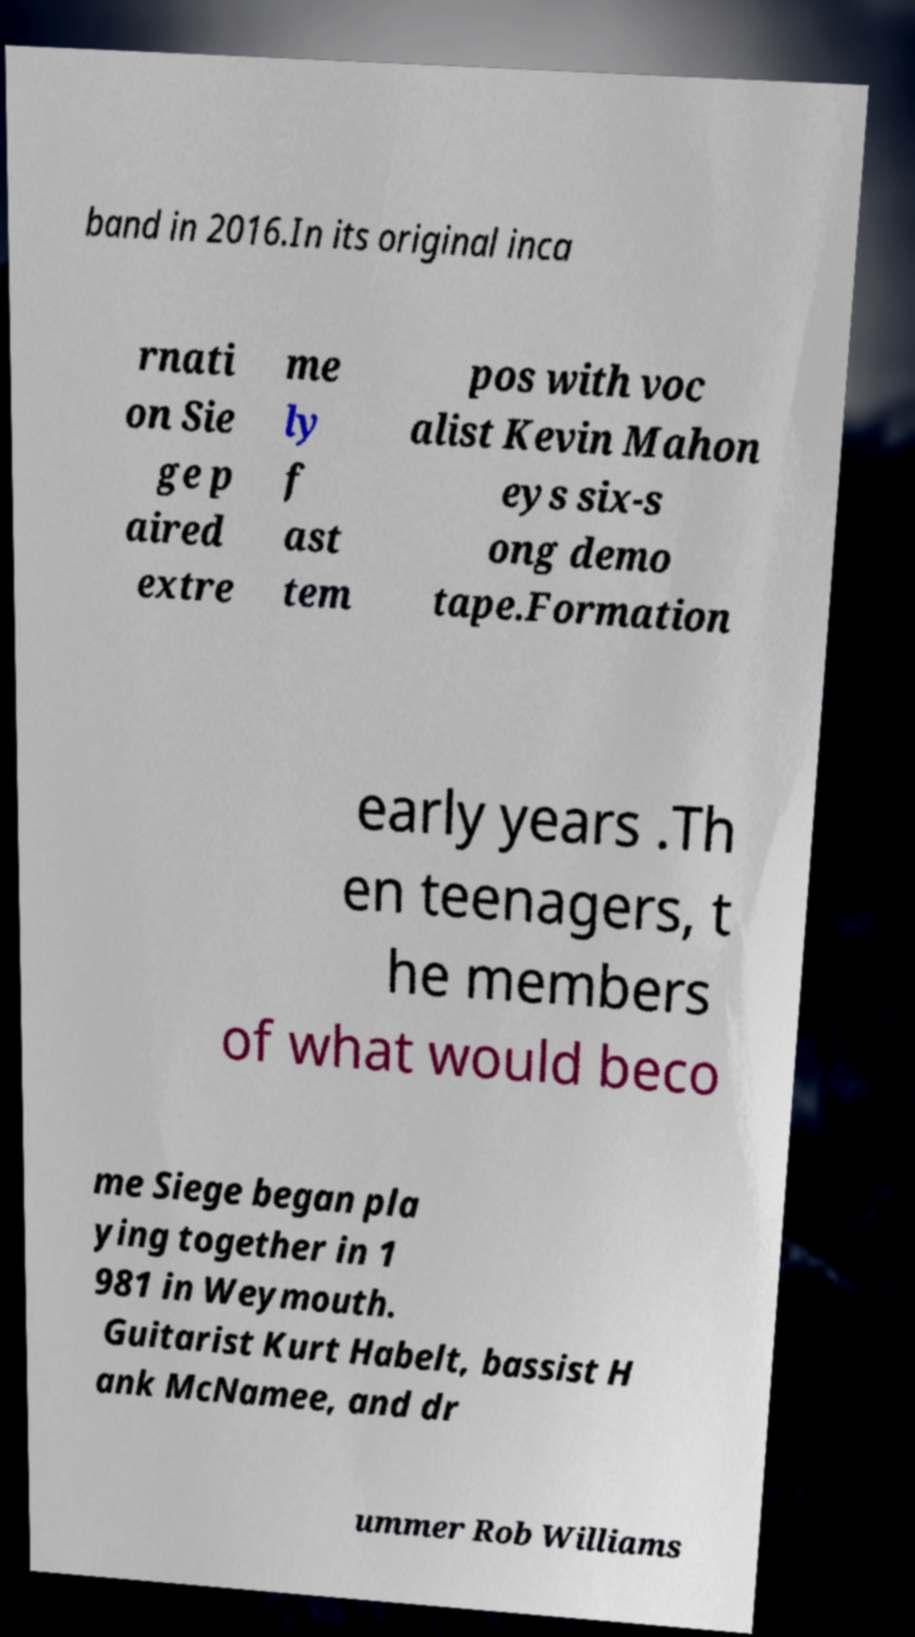Can you read and provide the text displayed in the image?This photo seems to have some interesting text. Can you extract and type it out for me? band in 2016.In its original inca rnati on Sie ge p aired extre me ly f ast tem pos with voc alist Kevin Mahon eys six-s ong demo tape.Formation early years .Th en teenagers, t he members of what would beco me Siege began pla ying together in 1 981 in Weymouth. Guitarist Kurt Habelt, bassist H ank McNamee, and dr ummer Rob Williams 